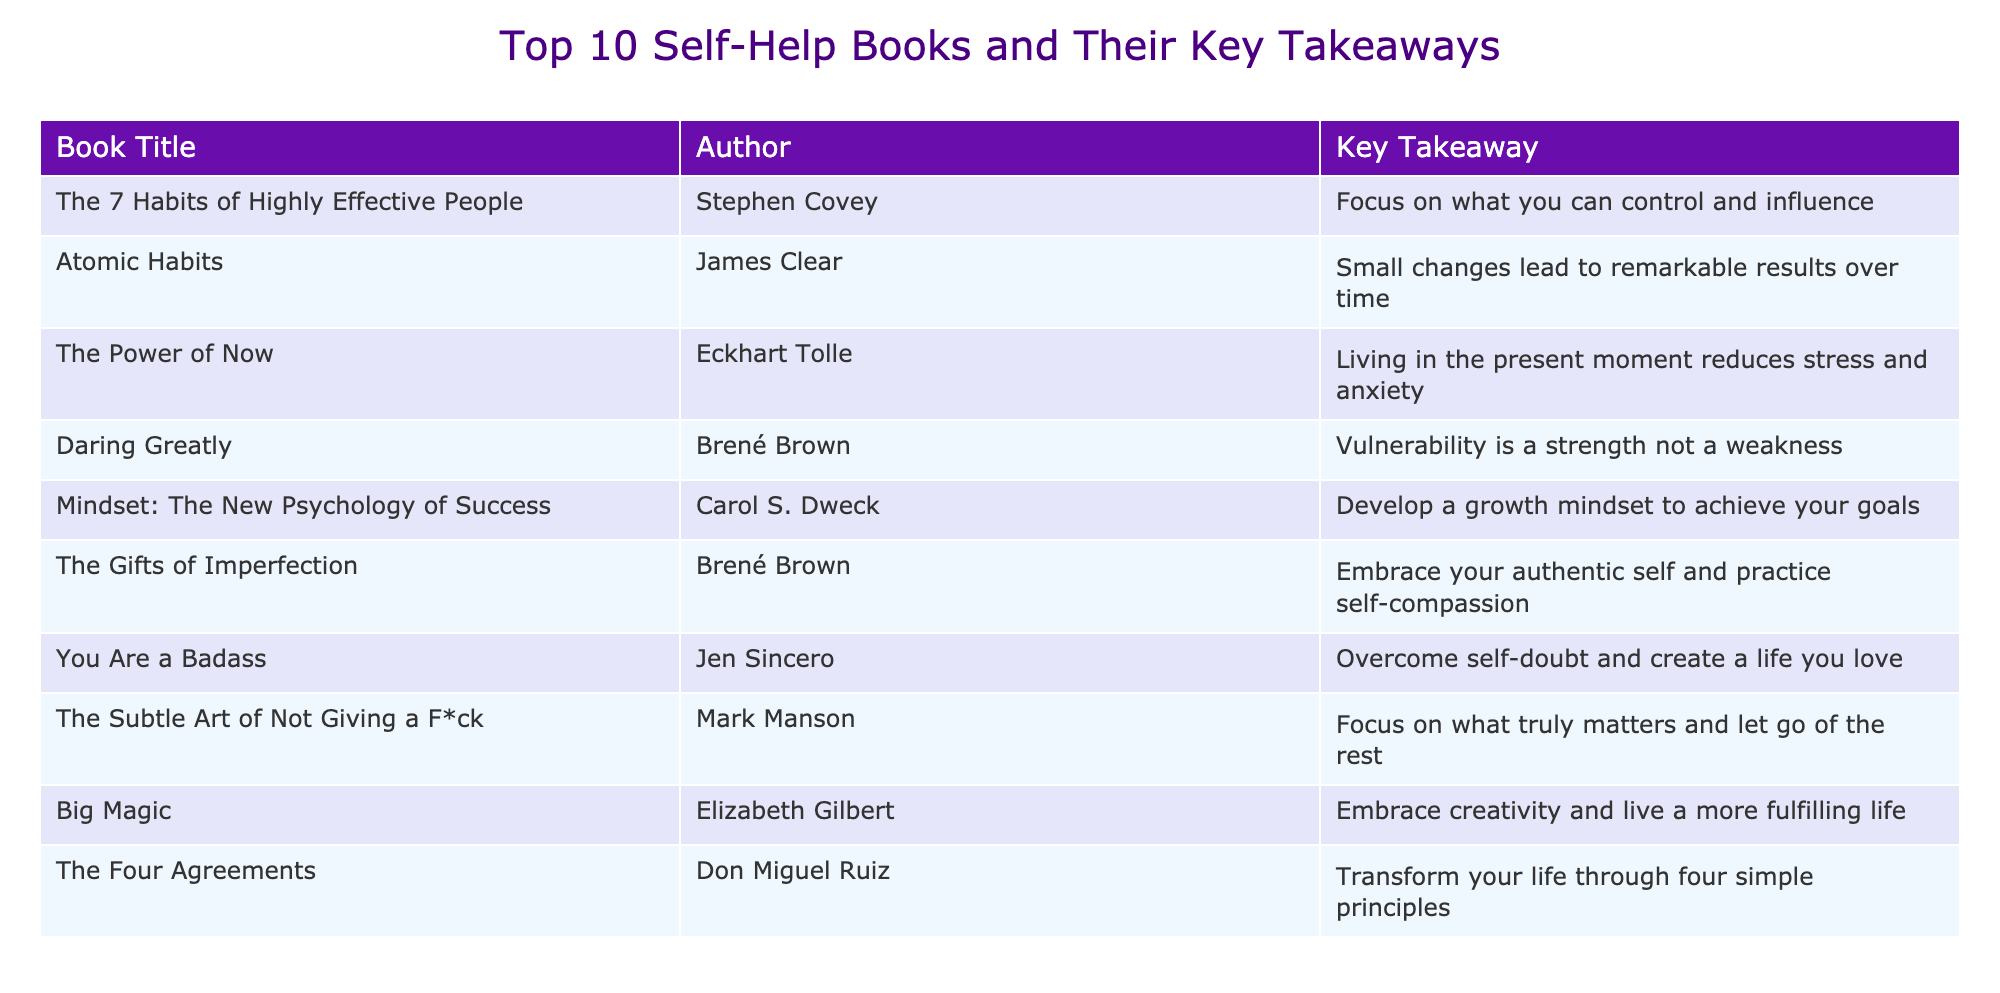What is the key takeaway from "The Power of Now"? The key takeaway is clearly stated in the table. It notes that living in the present moment reduces stress and anxiety.
Answer: Living in the present moment reduces stress and anxiety Which author wrote "Daring Greatly"? The table lists the author next to the book title. "Daring Greatly" is authored by Brené Brown.
Answer: Brené Brown How many books in the list focus on embracing authenticity or self-acceptance? Two books focus on this theme: "The Gifts of Imperfection" by Brené Brown and "You Are a Badass" by Jen Sincero. Counting those gives us a total of two.
Answer: 2 Is it true that "Atomic Habits" suggests that small changes can lead to significant results? According to the table, the key takeaway for "Atomic Habits" is that small changes lead to remarkable results over time, confirming the statement as true.
Answer: Yes If you combine the key takeaways from "The Four Agreements" and "The Subtle Art of Not Giving a F*ck," what overall message can be inferred about priorities? "The Four Agreements" emphasizes transforming life through simple principles, while "The Subtle Art of Not Giving a F*ck" suggests focusing on what truly matters. Together, these imply prioritizing meaningful principles in life. The inferred overall message is about the importance of prioritizing core values for a fulfilling life.
Answer: Prioritize meaningful values for fulfillment 